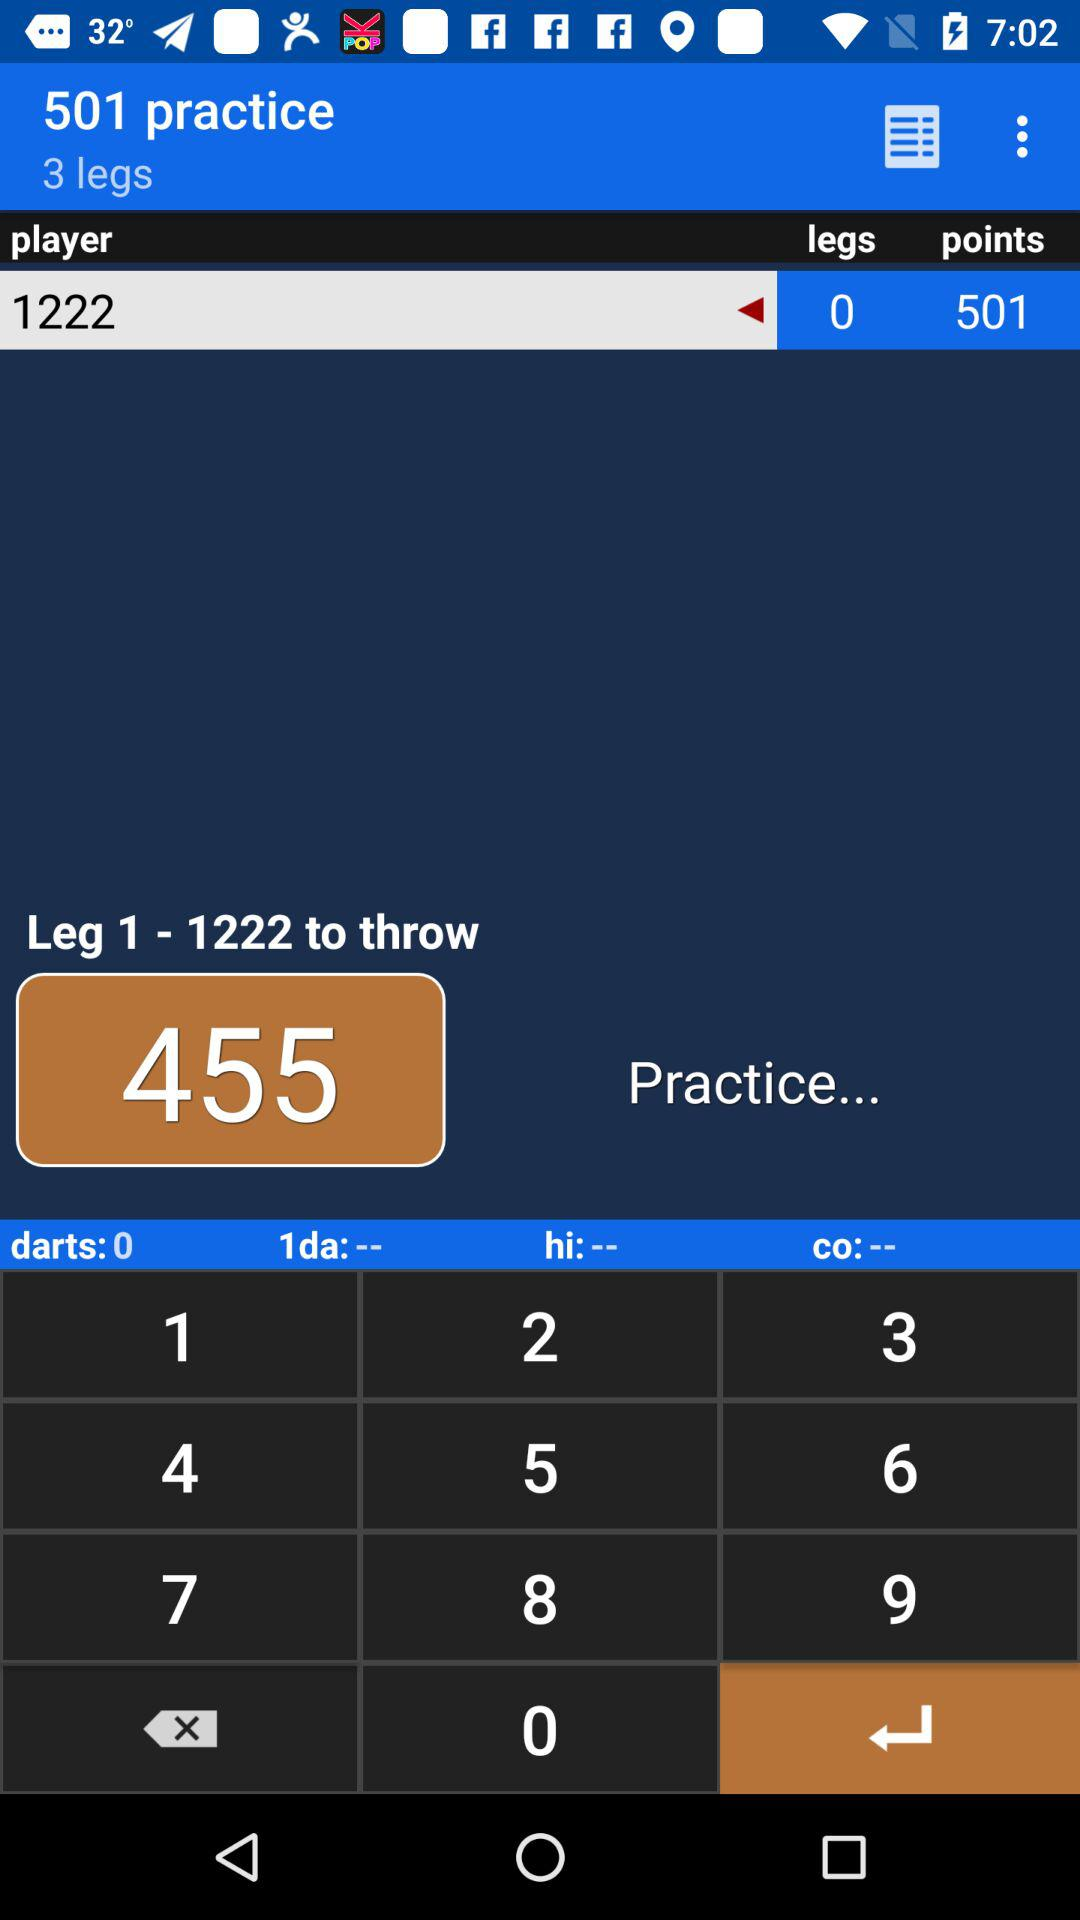How many legs are available to throw?
When the provided information is insufficient, respond with <no answer>. <no answer> 